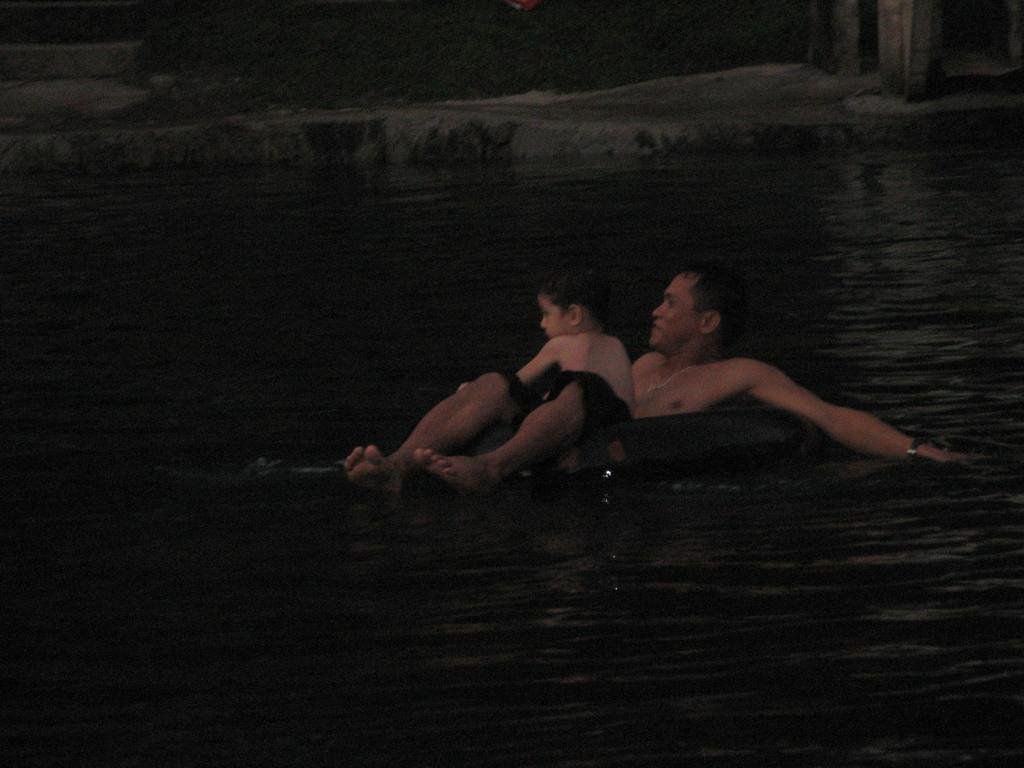Who is present in the image? There is a boy and a person sitting in a swimming tube in the image. What is the person sitting in the swimming tube doing? The person is sitting in a swimming tube that is placed on the water. How many cherries can be seen floating on the water in the image? There are no cherries present in the image; it features a boy and a person sitting in a swimming tube on the water. 